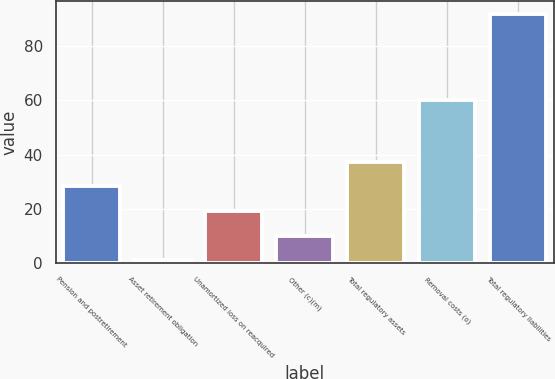Convert chart to OTSL. <chart><loc_0><loc_0><loc_500><loc_500><bar_chart><fcel>Pension and postretirement<fcel>Asset retirement obligation<fcel>Unamortized loss on reacquired<fcel>Other (c)(m)<fcel>Total regulatory assets<fcel>Removal costs (o)<fcel>Total regulatory liabilities<nl><fcel>28.3<fcel>1<fcel>19.2<fcel>10.1<fcel>37.4<fcel>60<fcel>92<nl></chart> 